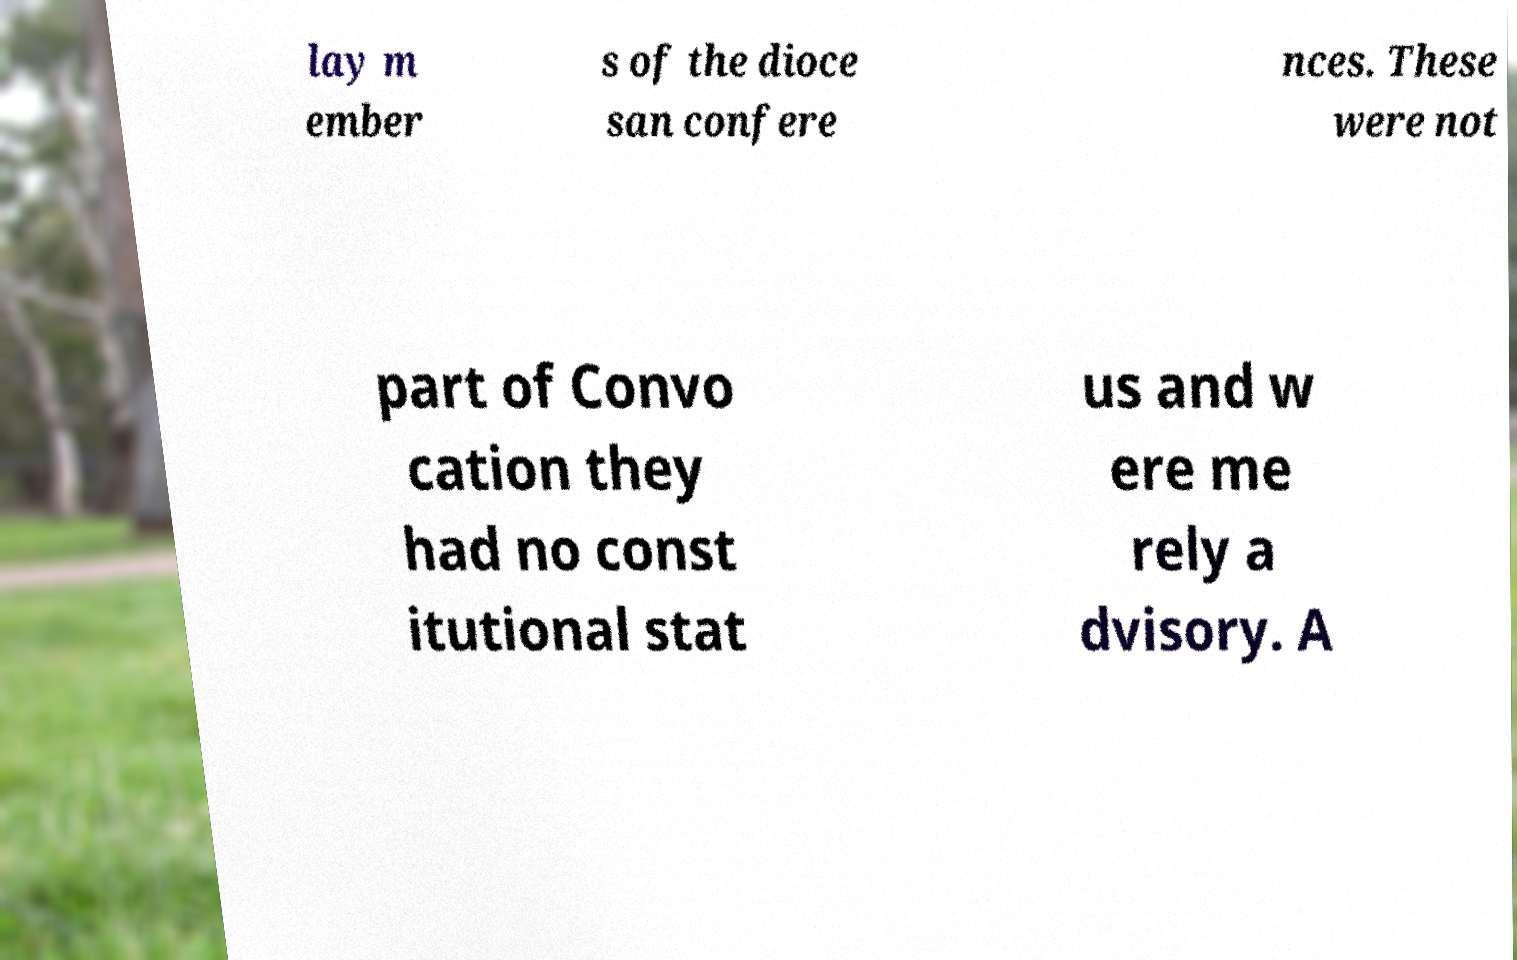I need the written content from this picture converted into text. Can you do that? lay m ember s of the dioce san confere nces. These were not part of Convo cation they had no const itutional stat us and w ere me rely a dvisory. A 